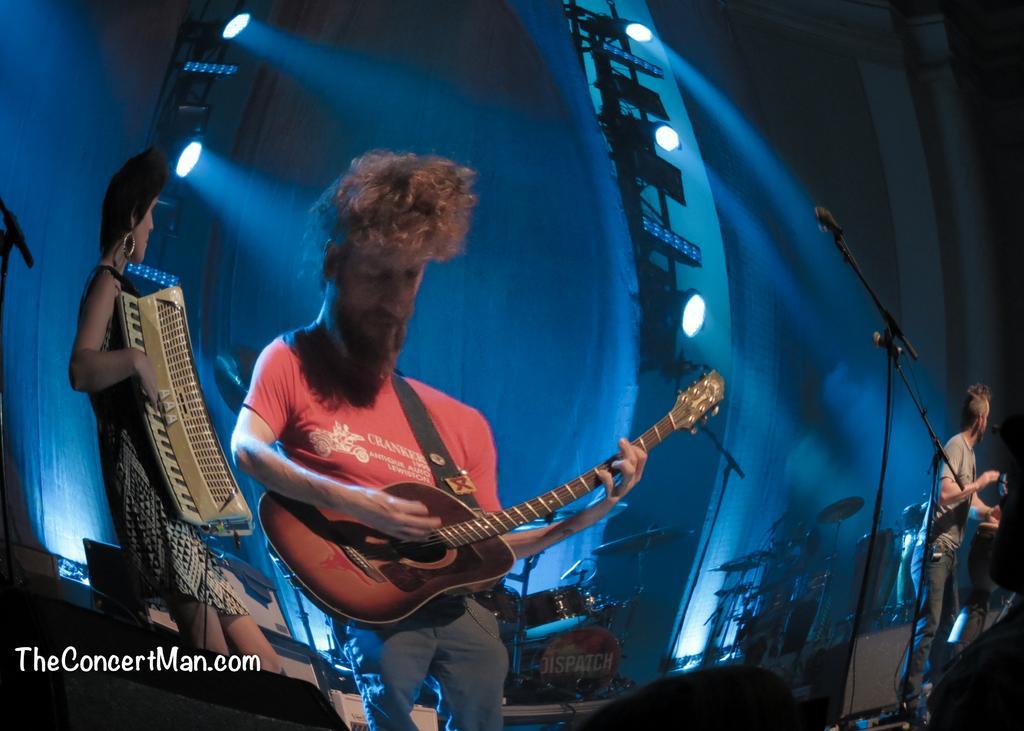Can you describe this image briefly? This is a picture of a members, who are playing the music instruments the man in red t shirt playing the guitar. This is a microphone and the stand. Background of this is a blue color with lights. This is a watermark. 